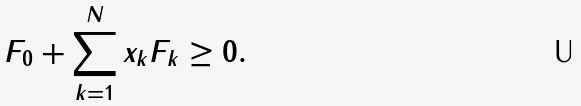Convert formula to latex. <formula><loc_0><loc_0><loc_500><loc_500>F _ { 0 } + \sum _ { k = 1 } ^ { N } x _ { k } F _ { k } \geq 0 .</formula> 